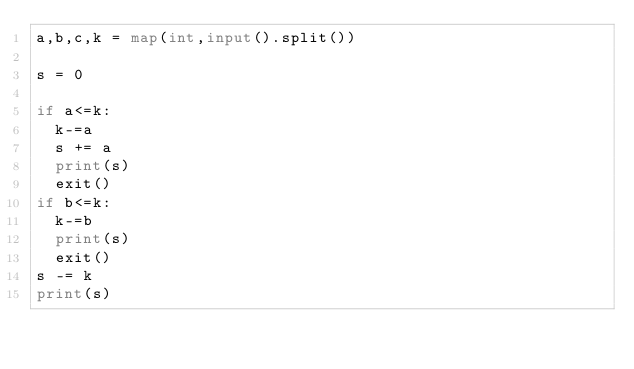Convert code to text. <code><loc_0><loc_0><loc_500><loc_500><_Python_>a,b,c,k = map(int,input().split())

s = 0

if a<=k:
  k-=a
  s += a
  print(s)
  exit()
if b<=k:
  k-=b
  print(s)
  exit()
s -= k
print(s)</code> 